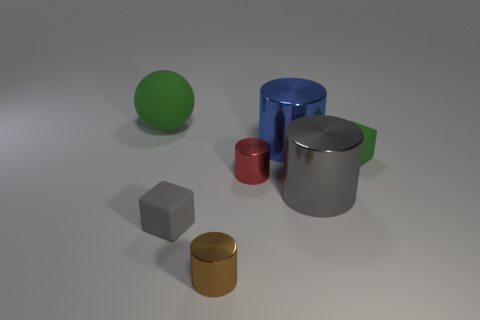How many other things are the same shape as the tiny brown thing?
Your answer should be compact. 3. There is a large blue metal cylinder; are there any red things to the right of it?
Provide a succinct answer. No. What color is the big ball?
Make the answer very short. Green. Do the ball and the rubber object that is to the right of the big gray cylinder have the same color?
Make the answer very short. Yes. Are there any green spheres that have the same size as the gray matte cube?
Offer a terse response. No. The matte block that is the same color as the big sphere is what size?
Make the answer very short. Small. What material is the cube left of the red shiny thing?
Ensure brevity in your answer.  Rubber. Are there an equal number of small red metal cylinders to the left of the big sphere and big gray shiny objects that are behind the large blue object?
Your answer should be very brief. Yes. Do the green object that is to the left of the red shiny cylinder and the green thing on the right side of the sphere have the same size?
Keep it short and to the point. No. What number of large rubber objects are the same color as the large rubber sphere?
Give a very brief answer. 0. 